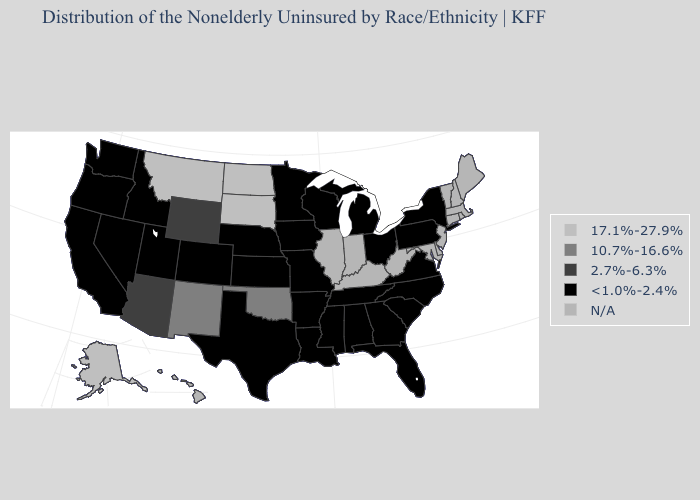What is the value of Ohio?
Write a very short answer. <1.0%-2.4%. Name the states that have a value in the range 10.7%-16.6%?
Write a very short answer. New Mexico, Oklahoma. What is the highest value in states that border Georgia?
Short answer required. <1.0%-2.4%. Name the states that have a value in the range N/A?
Be succinct. Connecticut, Delaware, Hawaii, Illinois, Indiana, Kentucky, Maine, Maryland, Massachusetts, New Hampshire, New Jersey, Rhode Island, Vermont, West Virginia. Does Oklahoma have the highest value in the South?
Give a very brief answer. Yes. What is the value of Pennsylvania?
Quick response, please. <1.0%-2.4%. Which states hav the highest value in the MidWest?
Short answer required. North Dakota, South Dakota. Which states have the lowest value in the West?
Write a very short answer. California, Colorado, Idaho, Nevada, Oregon, Utah, Washington. Which states hav the highest value in the MidWest?
Write a very short answer. North Dakota, South Dakota. Which states hav the highest value in the South?
Be succinct. Oklahoma. Name the states that have a value in the range 17.1%-27.9%?
Give a very brief answer. Alaska, Montana, North Dakota, South Dakota. 